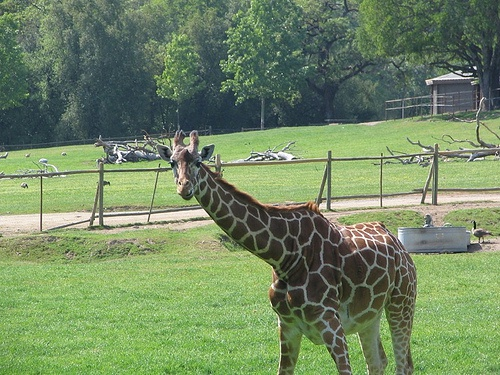Describe the objects in this image and their specific colors. I can see giraffe in purple, black, gray, and darkgreen tones, bird in purple, gray, black, and darkgray tones, bird in purple, ivory, darkgray, and gray tones, bird in purple, gray, beige, and darkgray tones, and bird in purple, darkgreen, and black tones in this image. 